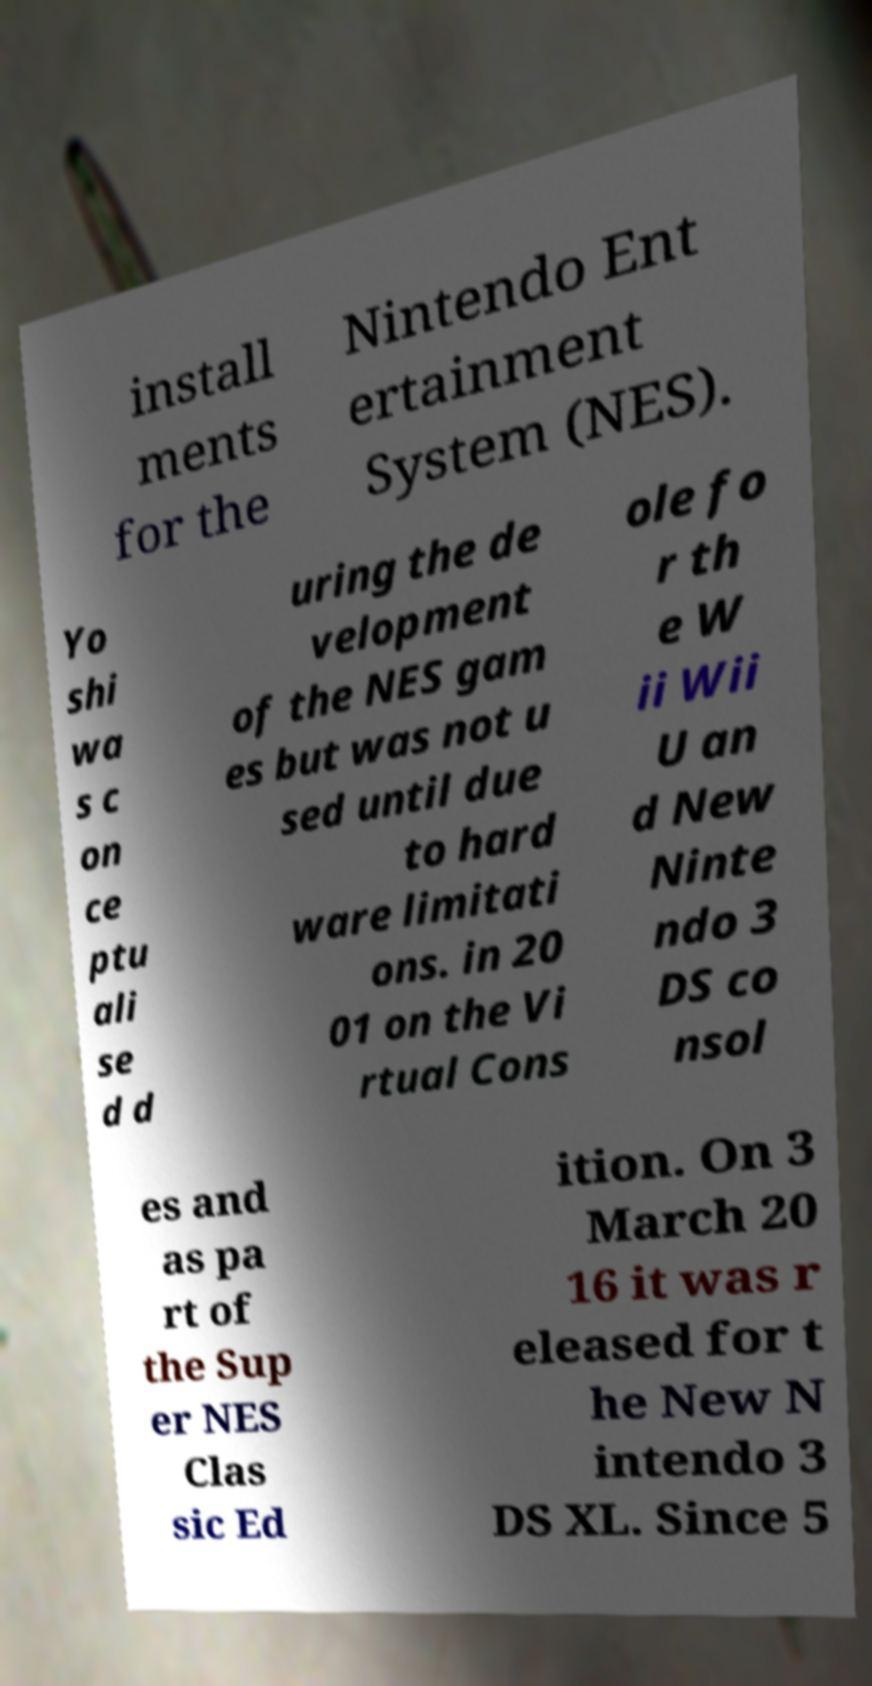What messages or text are displayed in this image? I need them in a readable, typed format. install ments for the Nintendo Ent ertainment System (NES). Yo shi wa s c on ce ptu ali se d d uring the de velopment of the NES gam es but was not u sed until due to hard ware limitati ons. in 20 01 on the Vi rtual Cons ole fo r th e W ii Wii U an d New Ninte ndo 3 DS co nsol es and as pa rt of the Sup er NES Clas sic Ed ition. On 3 March 20 16 it was r eleased for t he New N intendo 3 DS XL. Since 5 